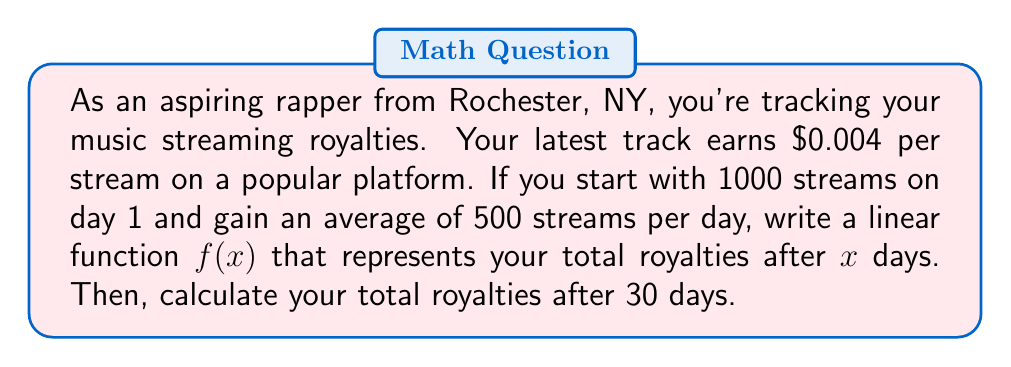Teach me how to tackle this problem. Let's approach this step-by-step:

1) First, we need to determine the rate of change for the streams:
   - You gain 500 streams per day
   - Each stream earns $0.004

   So, the daily increase in royalties is:
   $500 \times $0.004 = $2 per day

2) Next, we need to determine the initial value (y-intercept):
   - On day 1, you have 1000 streams
   - 1000 streams × $0.004 per stream = $4

3) Now we can write our linear function:
   $f(x) = mx + b$, where:
   $m = 2$ (slope, or daily increase)
   $b = 4$ (y-intercept, or initial value)

   Therefore, $f(x) = 2x + 4$

4) To calculate the royalties after 30 days, we substitute $x = 30$:

   $f(30) = 2(30) + 4$
   $f(30) = 60 + 4 = 64$

Thus, after 30 days, your total royalties would be $64.
Answer: $f(x) = 2x + 4$; $64 